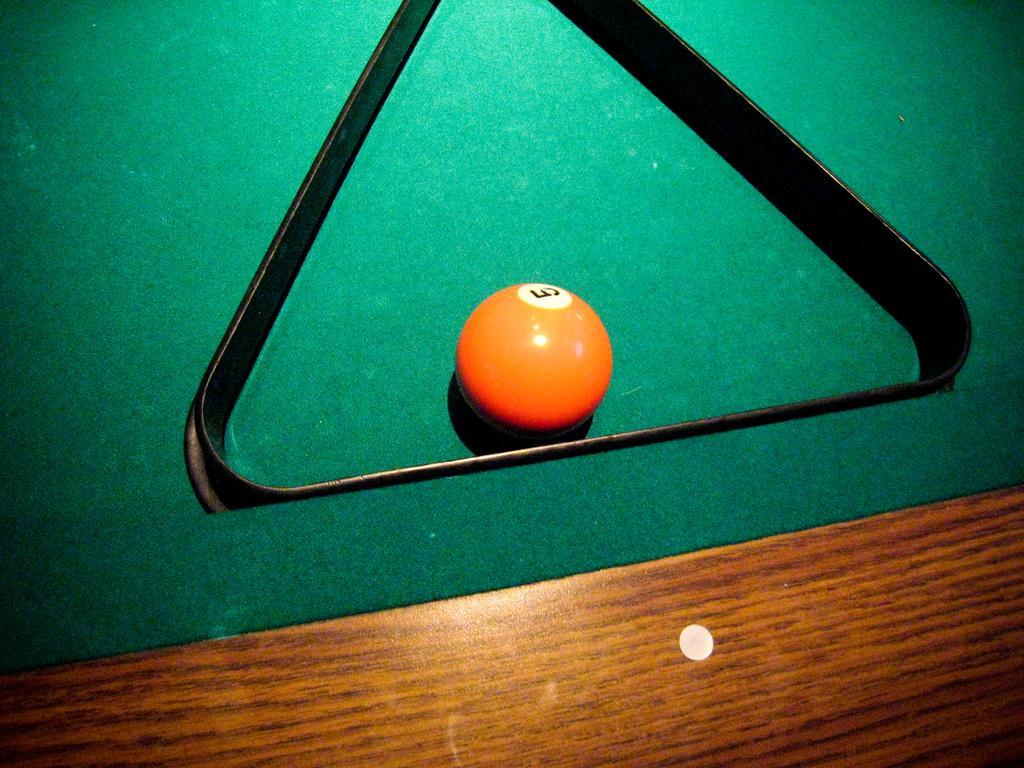Describe this image in one or two sentences. We can see ball and object on green surface. 